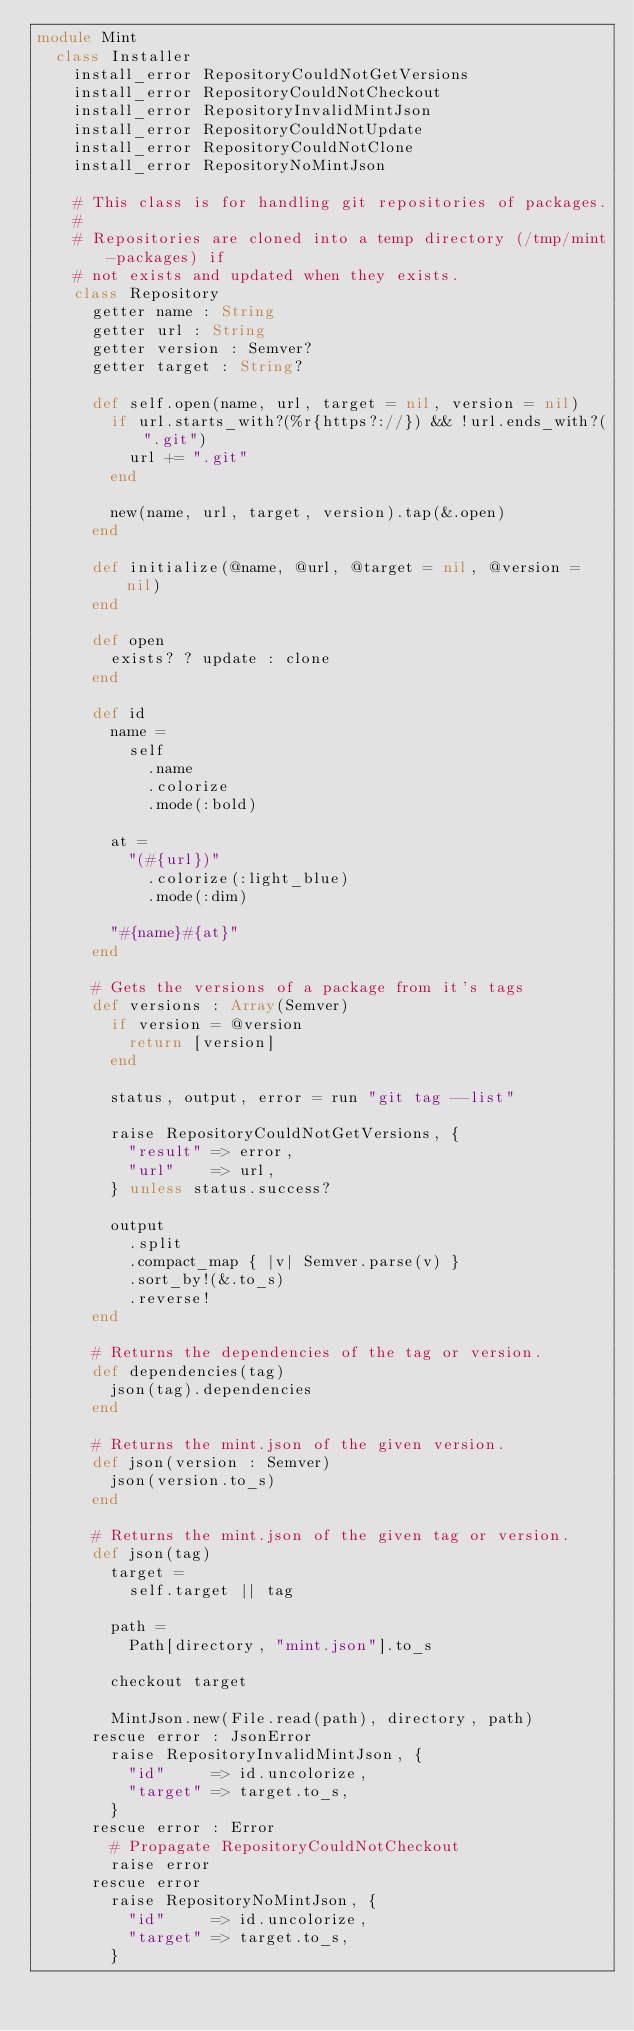Convert code to text. <code><loc_0><loc_0><loc_500><loc_500><_Crystal_>module Mint
  class Installer
    install_error RepositoryCouldNotGetVersions
    install_error RepositoryCouldNotCheckout
    install_error RepositoryInvalidMintJson
    install_error RepositoryCouldNotUpdate
    install_error RepositoryCouldNotClone
    install_error RepositoryNoMintJson

    # This class is for handling git repositories of packages.
    #
    # Repositories are cloned into a temp directory (/tmp/mint-packages) if
    # not exists and updated when they exists.
    class Repository
      getter name : String
      getter url : String
      getter version : Semver?
      getter target : String?

      def self.open(name, url, target = nil, version = nil)
        if url.starts_with?(%r{https?://}) && !url.ends_with?(".git")
          url += ".git"
        end

        new(name, url, target, version).tap(&.open)
      end

      def initialize(@name, @url, @target = nil, @version = nil)
      end

      def open
        exists? ? update : clone
      end

      def id
        name =
          self
            .name
            .colorize
            .mode(:bold)

        at =
          "(#{url})"
            .colorize(:light_blue)
            .mode(:dim)

        "#{name}#{at}"
      end

      # Gets the versions of a package from it's tags
      def versions : Array(Semver)
        if version = @version
          return [version]
        end

        status, output, error = run "git tag --list"

        raise RepositoryCouldNotGetVersions, {
          "result" => error,
          "url"    => url,
        } unless status.success?

        output
          .split
          .compact_map { |v| Semver.parse(v) }
          .sort_by!(&.to_s)
          .reverse!
      end

      # Returns the dependencies of the tag or version.
      def dependencies(tag)
        json(tag).dependencies
      end

      # Returns the mint.json of the given version.
      def json(version : Semver)
        json(version.to_s)
      end

      # Returns the mint.json of the given tag or version.
      def json(tag)
        target =
          self.target || tag

        path =
          Path[directory, "mint.json"].to_s

        checkout target

        MintJson.new(File.read(path), directory, path)
      rescue error : JsonError
        raise RepositoryInvalidMintJson, {
          "id"     => id.uncolorize,
          "target" => target.to_s,
        }
      rescue error : Error
        # Propagate RepositoryCouldNotCheckout
        raise error
      rescue error
        raise RepositoryNoMintJson, {
          "id"     => id.uncolorize,
          "target" => target.to_s,
        }</code> 